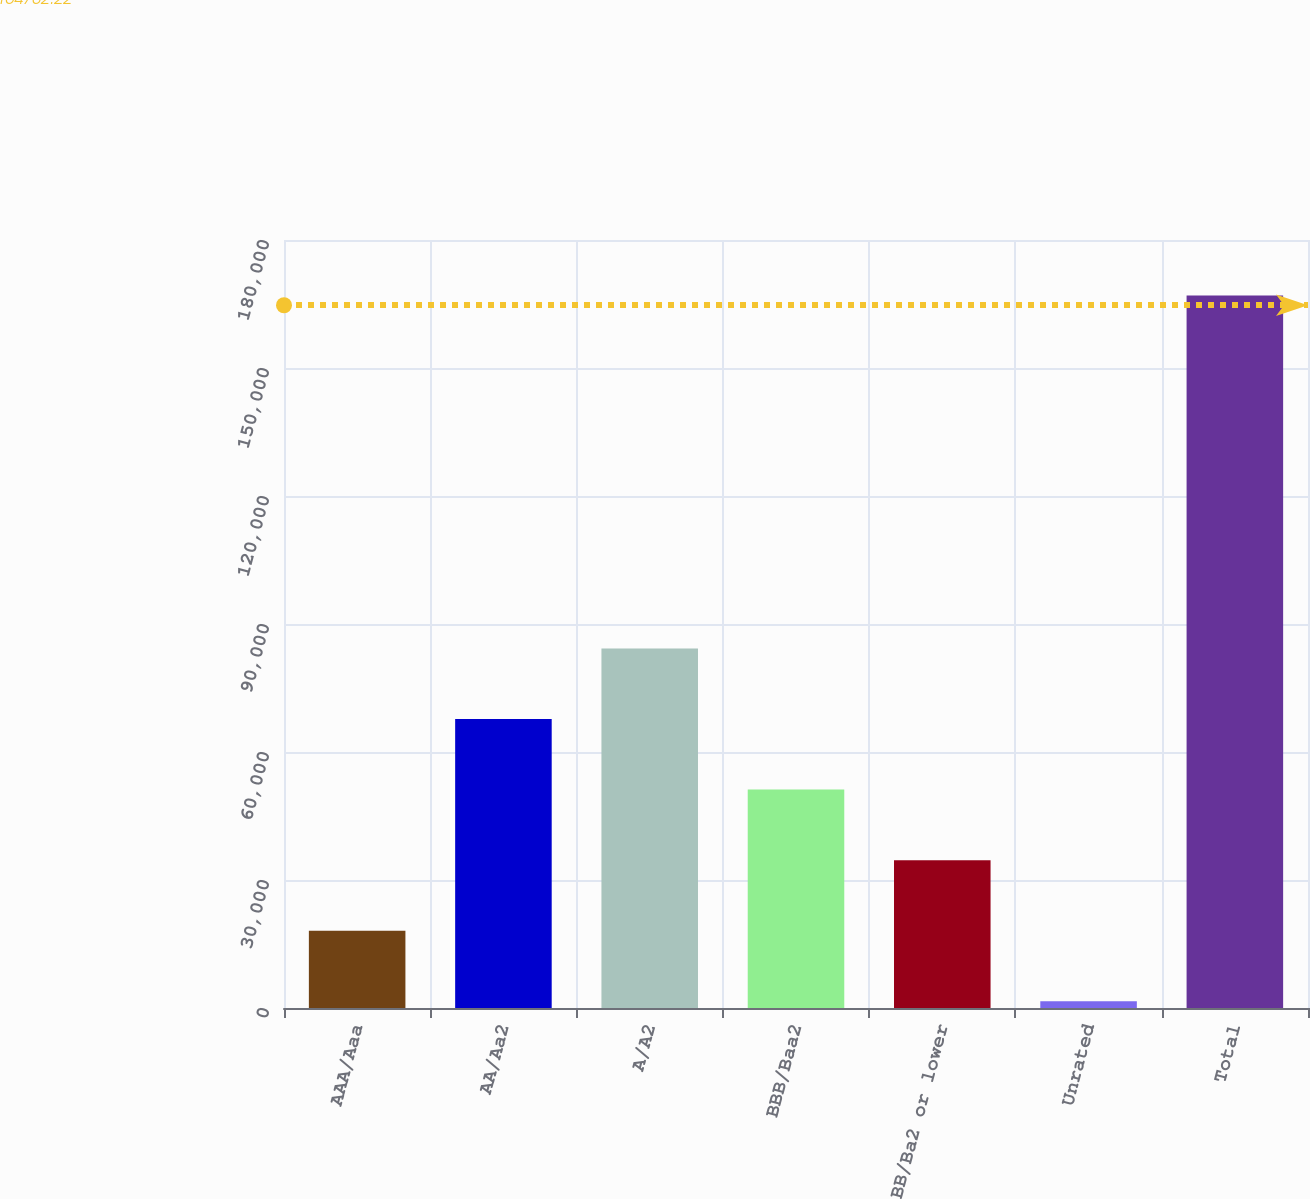Convert chart. <chart><loc_0><loc_0><loc_500><loc_500><bar_chart><fcel>AAA/Aaa<fcel>AA/Aa2<fcel>A/A2<fcel>BBB/Baa2<fcel>BB/Ba2 or lower<fcel>Unrated<fcel>Total<nl><fcel>18113.7<fcel>67738.8<fcel>84280.5<fcel>51197.1<fcel>34655.4<fcel>1572<fcel>166989<nl></chart> 